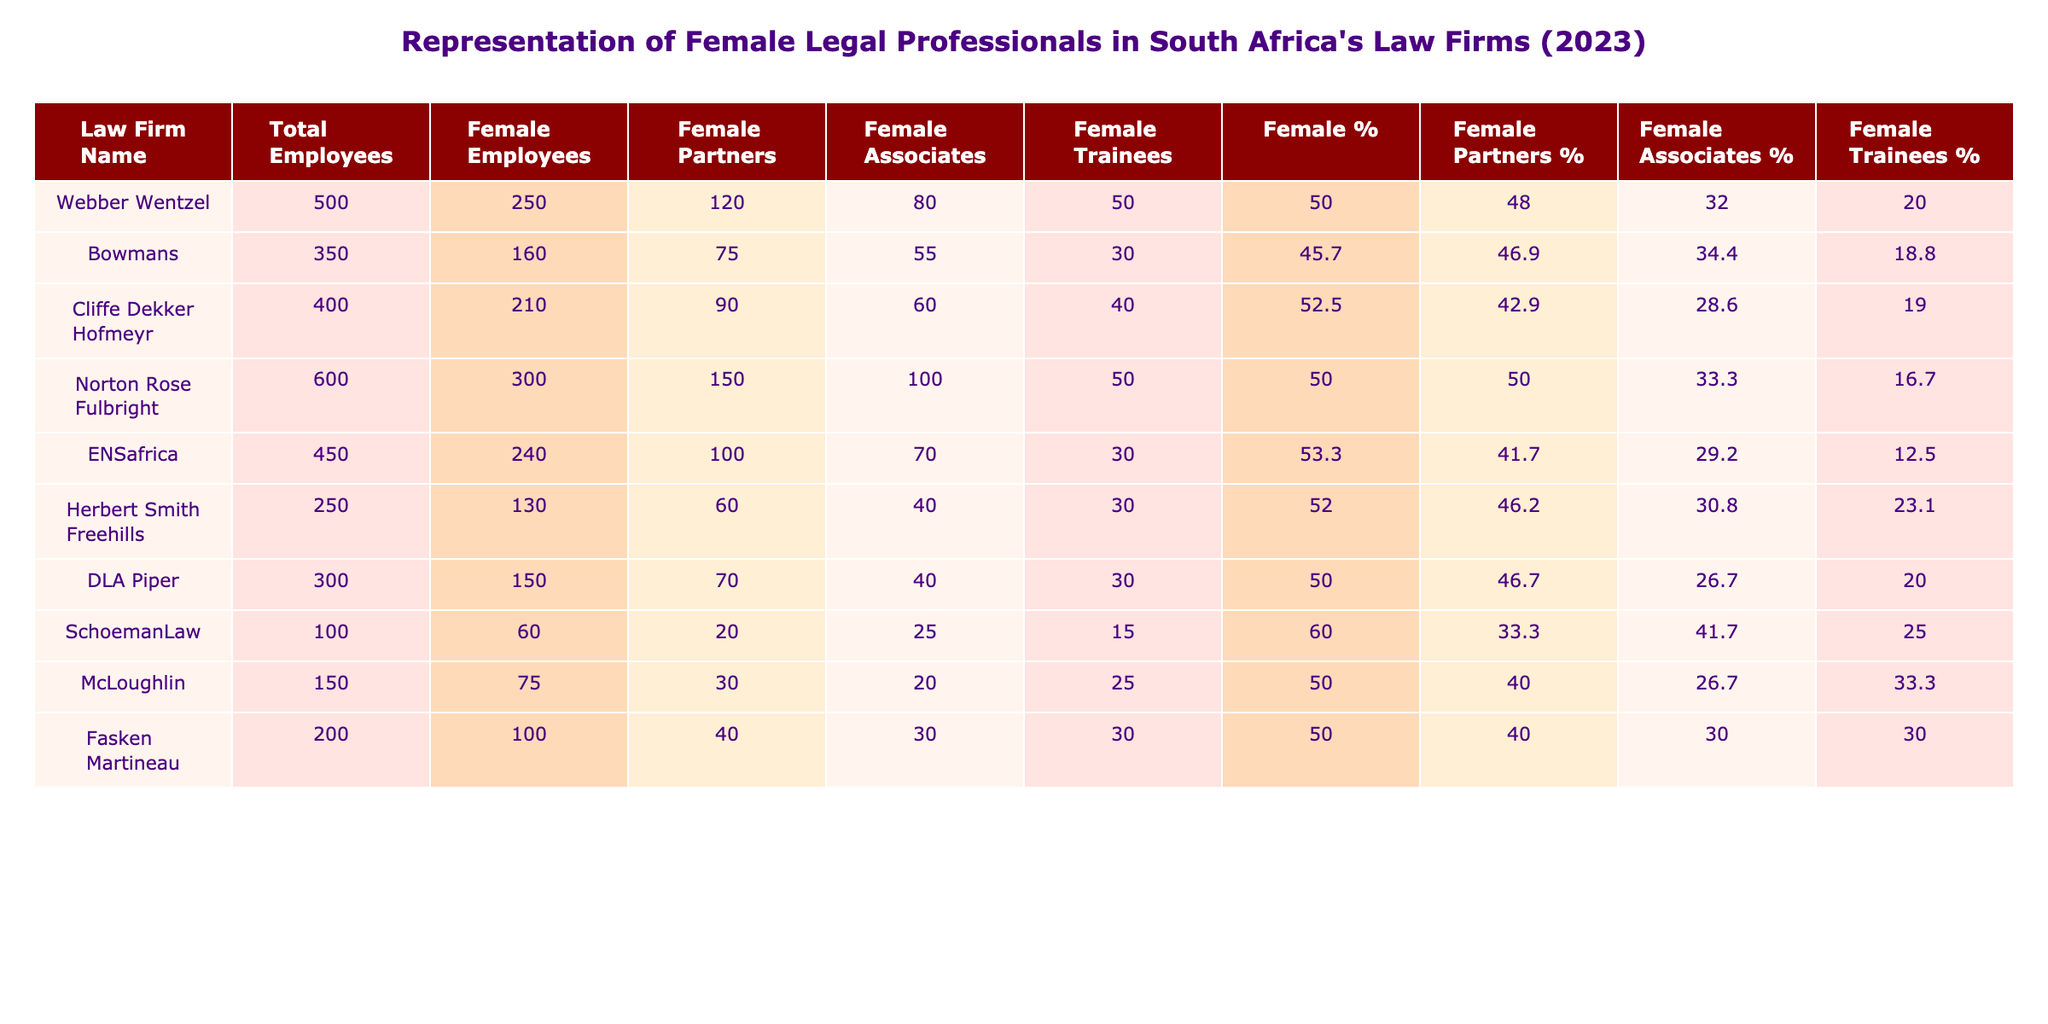What is the total number of female employees in Bowmans? The table shows that Bowmans has 160 female employees listed under the "Female Employees" column.
Answer: 160 Which law firm has the highest percentage of female partners? To find the firm with the highest percentage, we compare the "Female Partners %" values across the firms. The highest value is 80.0% from Webber Wentzel.
Answer: Webber Wentzel What is the average number of female trainees across all firms? We sum the number of female trainees from each firm: 50 + 30 + 40 + 50 + 30 + 30 + 30 + 15 + 25 + 30 = 350. There are 10 firms, so the average is 350/10 = 35.
Answer: 35 Is there any firm where the percentage of female associates is above 40%? We check the "Female Associates %" column and see that all firms have percentages above 40%, confirming that yes, there are firms with this characteristic.
Answer: Yes How many more female associates does Norton Rose Fulbright have compared to Cliffe Dekker Hofmeyr? We subtract the female associates of Cliffe Dekker Hofmeyr (60) from Norton Rose Fulbright (100): 100 - 60 = 40.
Answer: 40 What is the total number of female partners across all law firms? We sum the female partners across all firms: 120 + 75 + 90 + 150 + 100 + 60 + 70 + 20 + 30 + 40 =  835.
Answer: 835 Which firm has the lowest total number of employees and how many are female? The firm with the lowest total number of employees is SchoemanLaw with 100 total employees and 60 of them being female.
Answer: 60 Calculate the percentage of female employees at ENSafrica. To get the percentage, divide female employees (240) by total employees (450) and multiply by 100: (240/450)*100 = 53.3%.
Answer: 53.3% Are there more female trainees or female associates in Fasken Martineau? In Fasken Martineau, there are 30 female trainees and 30 female associates, making them equal.
Answer: Equal Which law firm has the lowest percentage of female employees? By comparing the "Female %" column, we find that SchoemanLaw has the lowest percentage at 60.0%.
Answer: SchoemanLaw 